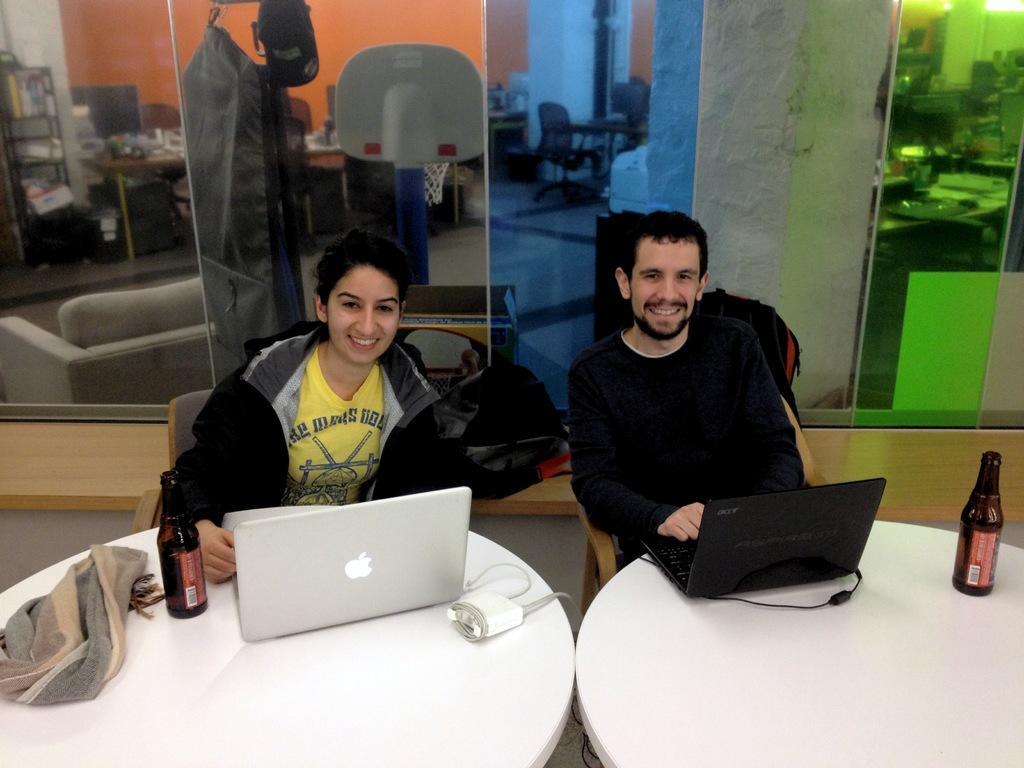Could you give a brief overview of what you see in this image? in this picture we can see a woman sitting on a chair and smiling, and in front there are laptop, wine bottle and some objects on the table, and beside her a man is sitting and holding a laptop, and at back there is a glass door, and at opposite there is a pillar, and beside there are bags on the floor. 